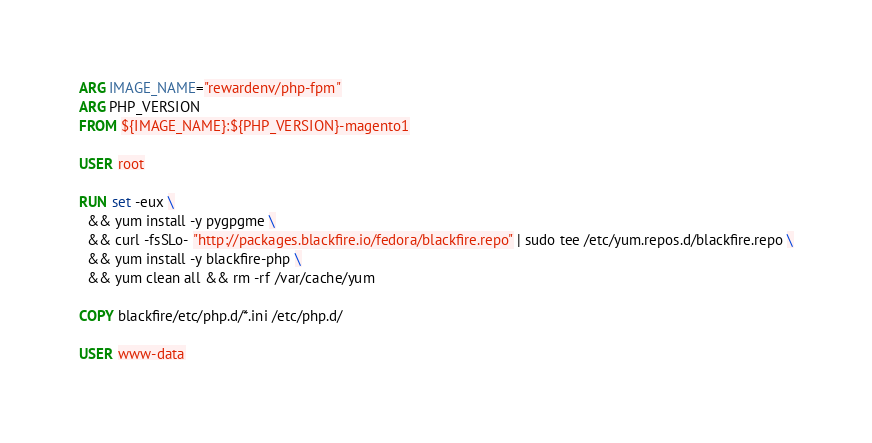<code> <loc_0><loc_0><loc_500><loc_500><_Dockerfile_>ARG IMAGE_NAME="rewardenv/php-fpm"
ARG PHP_VERSION
FROM ${IMAGE_NAME}:${PHP_VERSION}-magento1

USER root

RUN set -eux \
  && yum install -y pygpgme \
  && curl -fsSLo- "http://packages.blackfire.io/fedora/blackfire.repo" | sudo tee /etc/yum.repos.d/blackfire.repo \
  && yum install -y blackfire-php \
  && yum clean all && rm -rf /var/cache/yum

COPY blackfire/etc/php.d/*.ini /etc/php.d/

USER www-data
</code> 